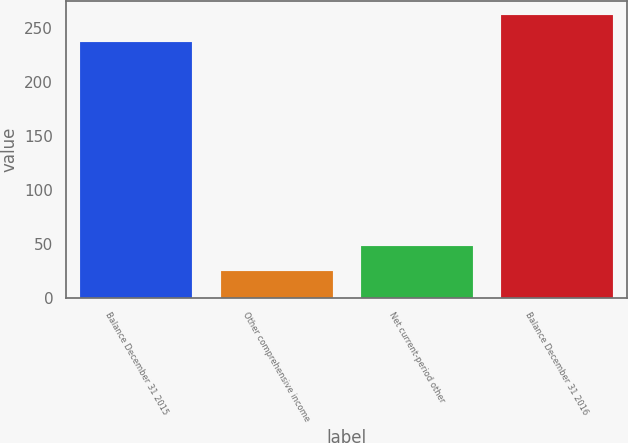<chart> <loc_0><loc_0><loc_500><loc_500><bar_chart><fcel>Balance December 31 2015<fcel>Other comprehensive income<fcel>Net current-period other<fcel>Balance December 31 2016<nl><fcel>237.4<fcel>24.6<fcel>48.34<fcel>262<nl></chart> 